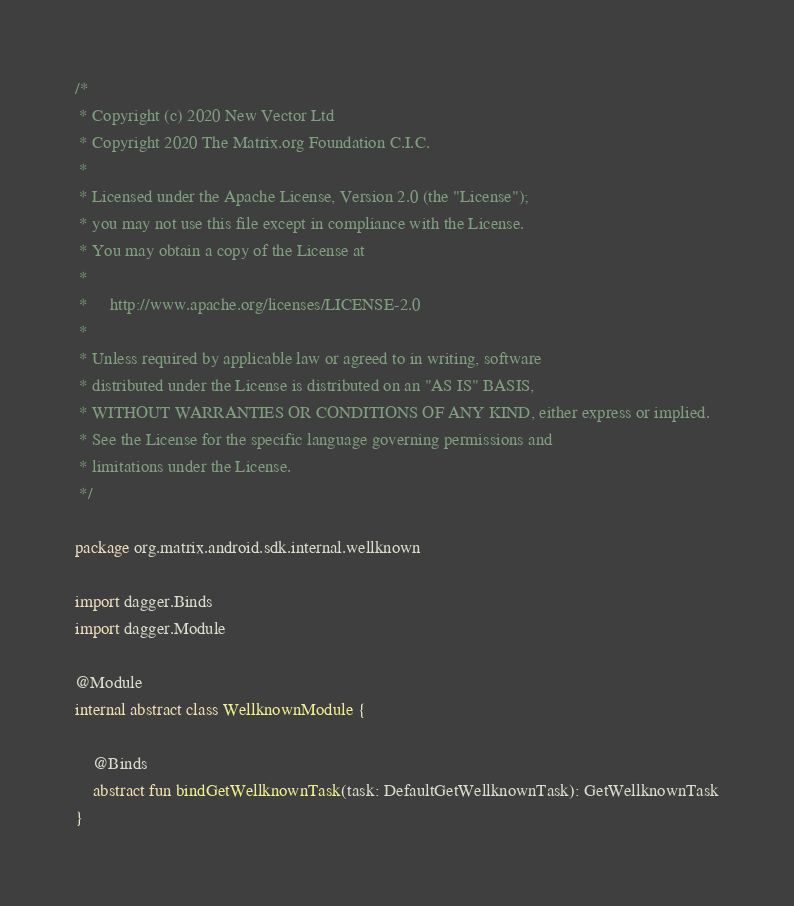<code> <loc_0><loc_0><loc_500><loc_500><_Kotlin_>/*
 * Copyright (c) 2020 New Vector Ltd
 * Copyright 2020 The Matrix.org Foundation C.I.C.
 *
 * Licensed under the Apache License, Version 2.0 (the "License");
 * you may not use this file except in compliance with the License.
 * You may obtain a copy of the License at
 *
 *     http://www.apache.org/licenses/LICENSE-2.0
 *
 * Unless required by applicable law or agreed to in writing, software
 * distributed under the License is distributed on an "AS IS" BASIS,
 * WITHOUT WARRANTIES OR CONDITIONS OF ANY KIND, either express or implied.
 * See the License for the specific language governing permissions and
 * limitations under the License.
 */

package org.matrix.android.sdk.internal.wellknown

import dagger.Binds
import dagger.Module

@Module
internal abstract class WellknownModule {

    @Binds
    abstract fun bindGetWellknownTask(task: DefaultGetWellknownTask): GetWellknownTask
}
</code> 